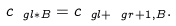<formula> <loc_0><loc_0><loc_500><loc_500>c _ { \ g l * B } = c _ { \ g l + \ g r + 1 , B } .</formula> 